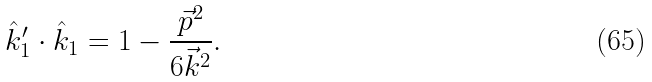<formula> <loc_0><loc_0><loc_500><loc_500>\hat { k } _ { 1 } ^ { \prime } \cdot \hat { k } _ { 1 } = 1 - \frac { \vec { p } ^ { 2 } } { 6 \vec { k } ^ { 2 } } .</formula> 